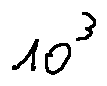Convert formula to latex. <formula><loc_0><loc_0><loc_500><loc_500>1 0 ^ { 3 }</formula> 